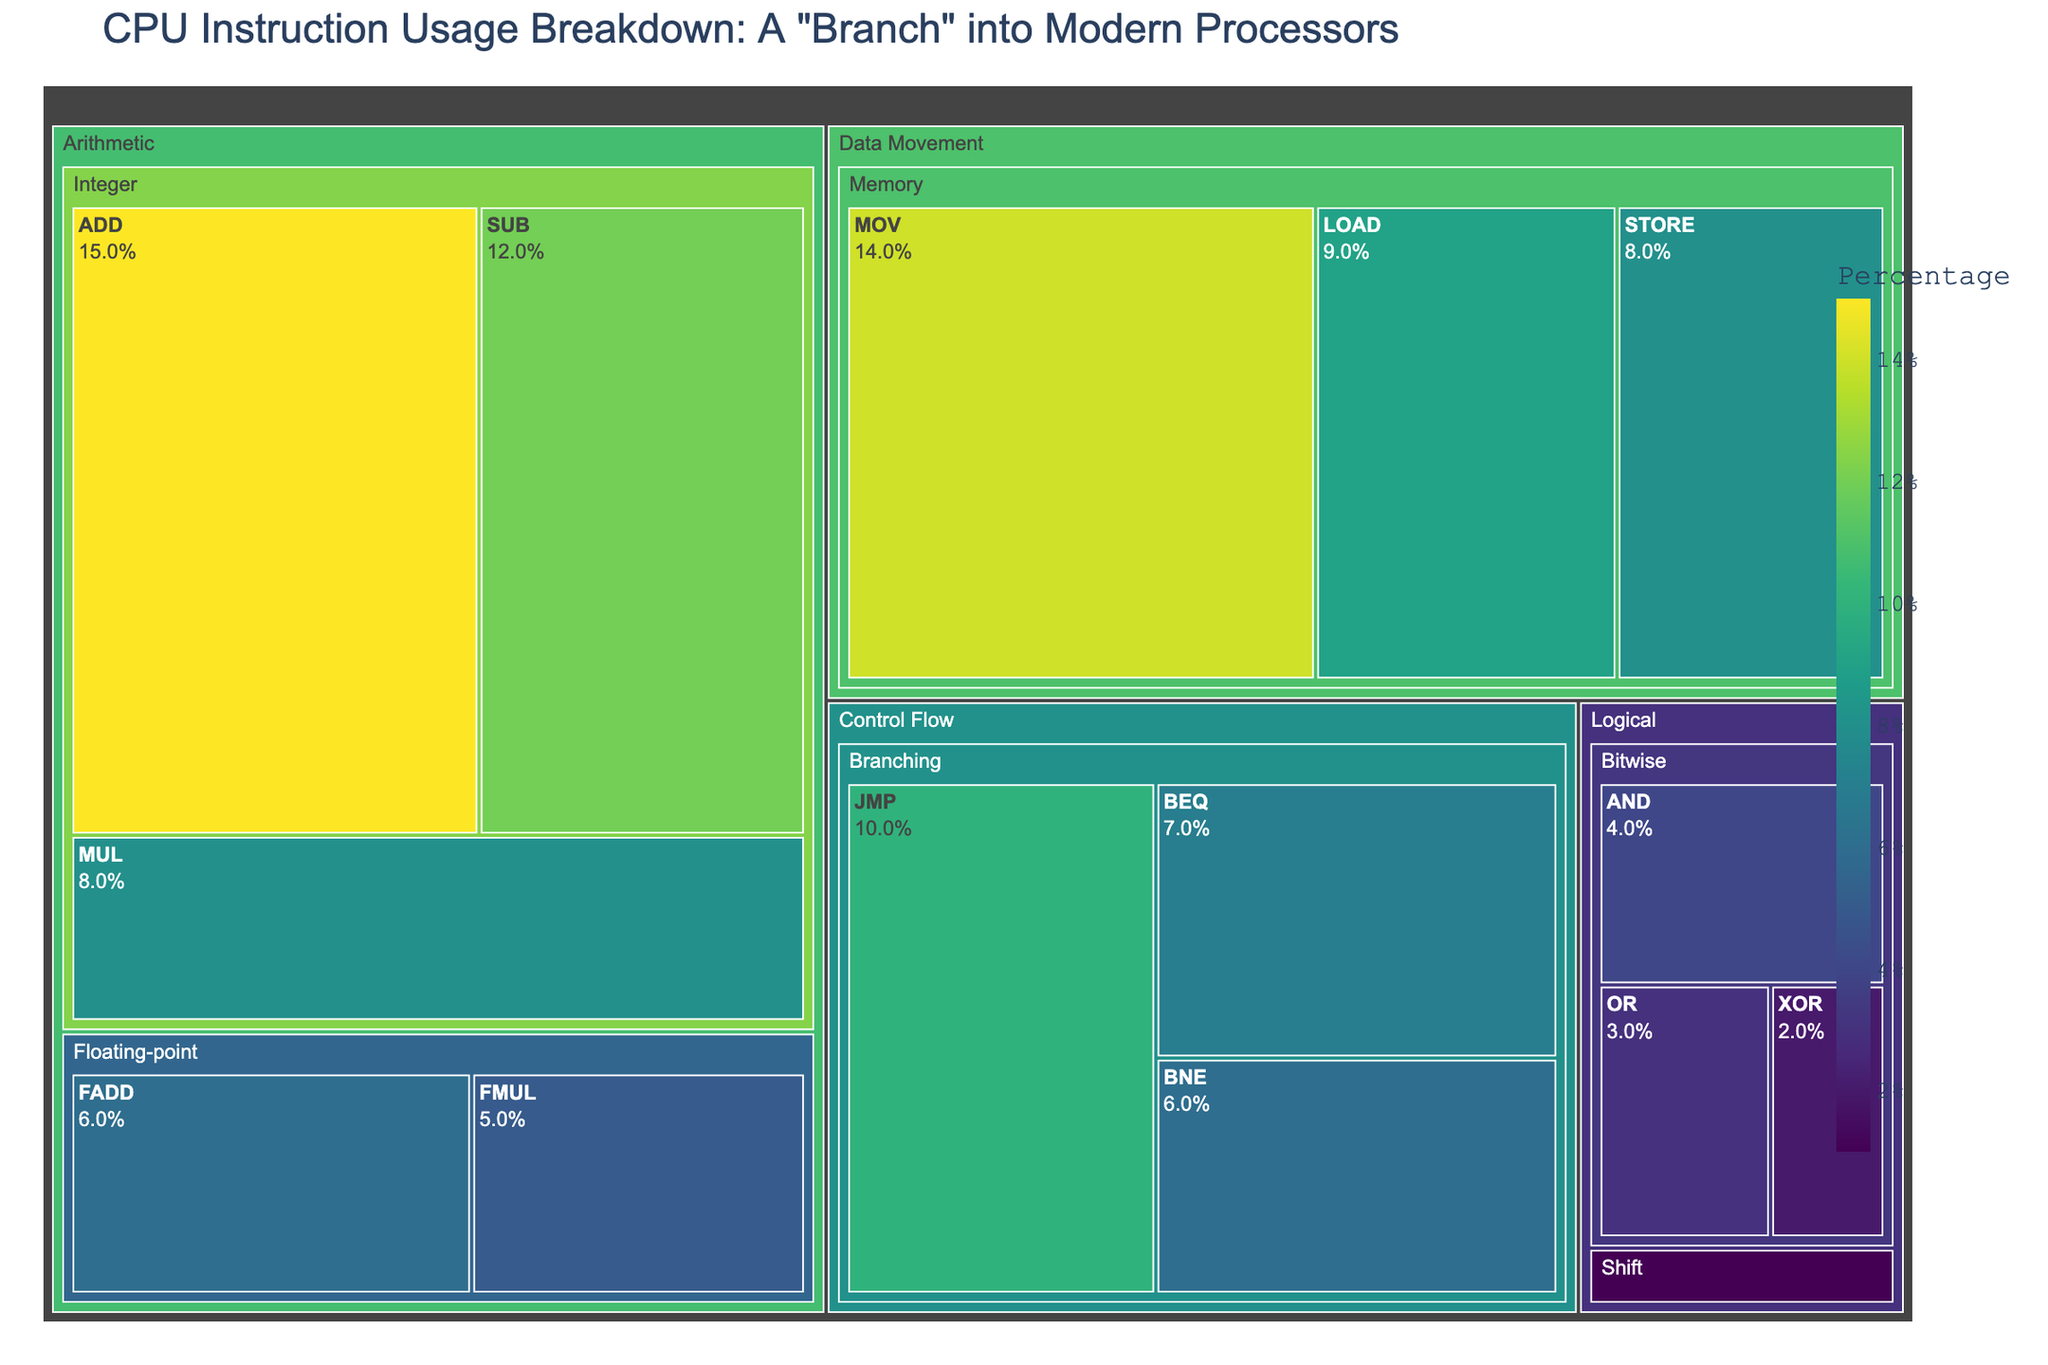what is the title of the figure? The title is found at the top of the figure. It summarizes the theme of the treemap.
Answer: CPU Instruction Usage Breakdown: A "Branch" into Modern Processors Which instruction has the highest percentage? Locate the instruction with the largest area and the highest percentage value labeled on the figure.
Answer: ADD What is the total percentage of Arithmetic category? Sum the percentages of all instructions under the Arithmetic category.
Answer: 46% Which instruction has a higher percentage: MUL or STORE? Compare the percentage values of the MULT and STORE instructions as labeled on the figure.
Answer: MUL How does the percentage of MOV compare to the combined percentage of all Logical instructions? Calculate the combined percentage of all Logical instructions (AND, OR, XOR, SHL) and compare it with the percentage of MOV.
Answer: MOV (14%) is greater than all Logical instructions combined (10%) What is the overall percentage for Control Flow category? Sum the percentages of all instructions under Control Flow category.
Answer: 23% Which has a greater percentage: Branching in Control Flow or Memory in Data Movement? Sum the percentages of all Branching instructions and compare with the sum of all Memory instructions.
Answer: Branching (23%) is less than Memory (31%) What is the difference in percentage between ADD and MUL? Subtract the percentage of MUL from that of ADD.
Answer: 7% Which subcategory within Logical instructions has the smallest percentage? Identify the instruction with the smallest percentage in the Logical category.
Answer: SHL 